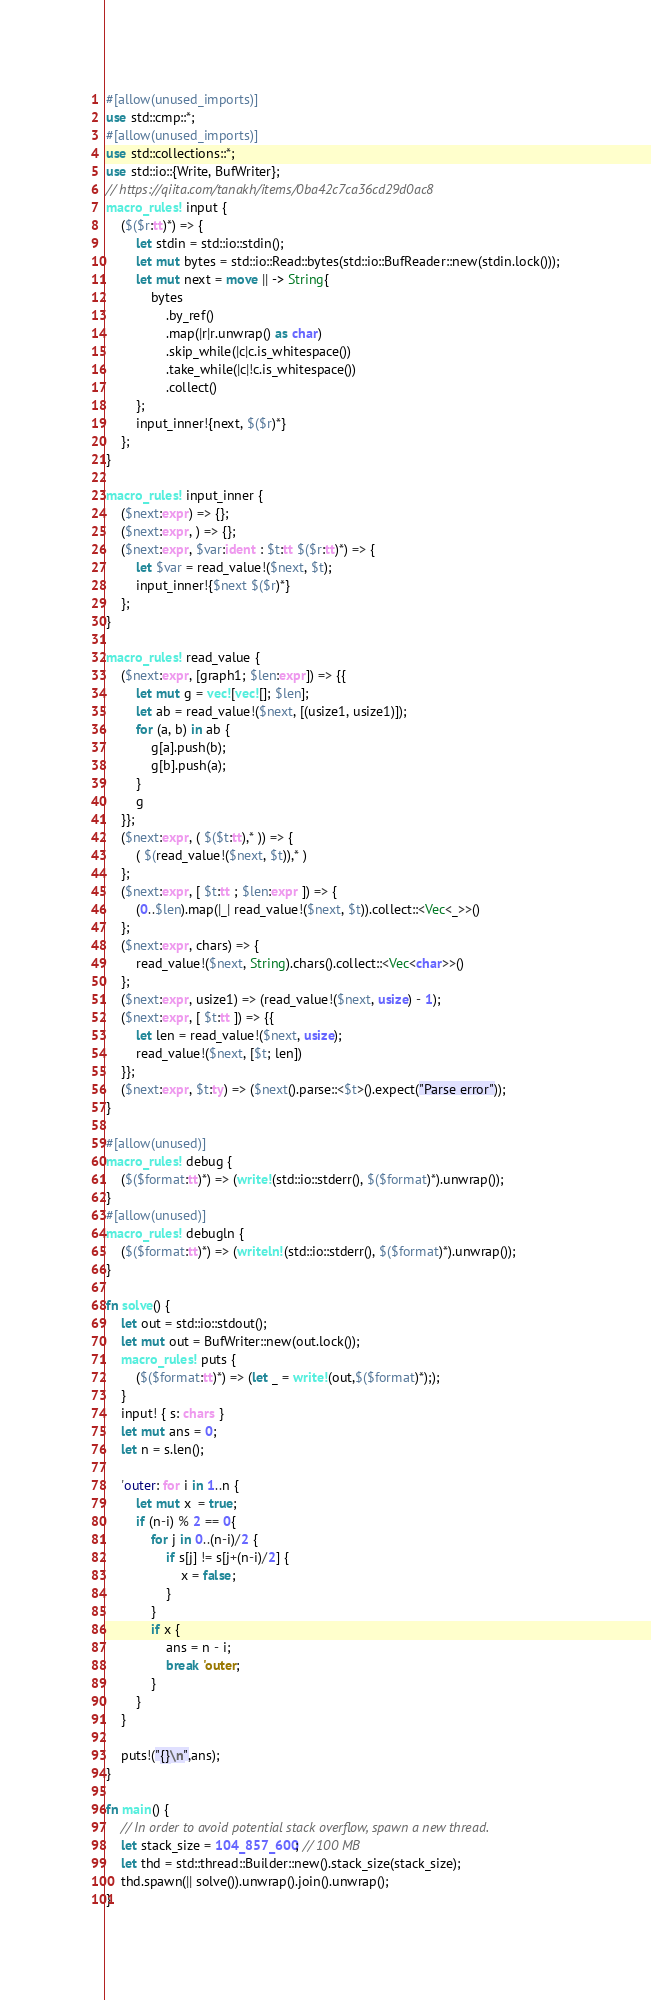<code> <loc_0><loc_0><loc_500><loc_500><_Rust_>#[allow(unused_imports)]
use std::cmp::*;
#[allow(unused_imports)]
use std::collections::*;
use std::io::{Write, BufWriter};
// https://qiita.com/tanakh/items/0ba42c7ca36cd29d0ac8
macro_rules! input {
    ($($r:tt)*) => {
        let stdin = std::io::stdin();
        let mut bytes = std::io::Read::bytes(std::io::BufReader::new(stdin.lock()));
        let mut next = move || -> String{
            bytes
                .by_ref()
                .map(|r|r.unwrap() as char)
                .skip_while(|c|c.is_whitespace())
                .take_while(|c|!c.is_whitespace())
                .collect()
        };
        input_inner!{next, $($r)*}
    };
}

macro_rules! input_inner {
    ($next:expr) => {};
    ($next:expr, ) => {};
    ($next:expr, $var:ident : $t:tt $($r:tt)*) => {
        let $var = read_value!($next, $t);
        input_inner!{$next $($r)*}
    };
}

macro_rules! read_value {
    ($next:expr, [graph1; $len:expr]) => {{
        let mut g = vec![vec![]; $len];
        let ab = read_value!($next, [(usize1, usize1)]);
        for (a, b) in ab {
            g[a].push(b);
            g[b].push(a);
        }
        g
    }};
    ($next:expr, ( $($t:tt),* )) => {
        ( $(read_value!($next, $t)),* )
    };
    ($next:expr, [ $t:tt ; $len:expr ]) => {
        (0..$len).map(|_| read_value!($next, $t)).collect::<Vec<_>>()
    };
    ($next:expr, chars) => {
        read_value!($next, String).chars().collect::<Vec<char>>()
    };
    ($next:expr, usize1) => (read_value!($next, usize) - 1);
    ($next:expr, [ $t:tt ]) => {{
        let len = read_value!($next, usize);
        read_value!($next, [$t; len])
    }};
    ($next:expr, $t:ty) => ($next().parse::<$t>().expect("Parse error"));
}

#[allow(unused)]
macro_rules! debug {
    ($($format:tt)*) => (write!(std::io::stderr(), $($format)*).unwrap());
}
#[allow(unused)]
macro_rules! debugln {
    ($($format:tt)*) => (writeln!(std::io::stderr(), $($format)*).unwrap());
}

fn solve() {
    let out = std::io::stdout();
    let mut out = BufWriter::new(out.lock());
    macro_rules! puts {
        ($($format:tt)*) => (let _ = write!(out,$($format)*););
    }
    input! { s: chars }
    let mut ans = 0;
    let n = s.len();

    'outer: for i in 1..n {
        let mut x  = true;
        if (n-i) % 2 == 0{
            for j in 0..(n-i)/2 {
                if s[j] != s[j+(n-i)/2] {
                    x = false;
                }
            }
            if x {
                ans = n - i;
                break 'outer;
            }
        }
    }

    puts!("{}\n",ans);
}

fn main() {
    // In order to avoid potential stack overflow, spawn a new thread.
    let stack_size = 104_857_600; // 100 MB
    let thd = std::thread::Builder::new().stack_size(stack_size);
    thd.spawn(|| solve()).unwrap().join().unwrap();
}
</code> 